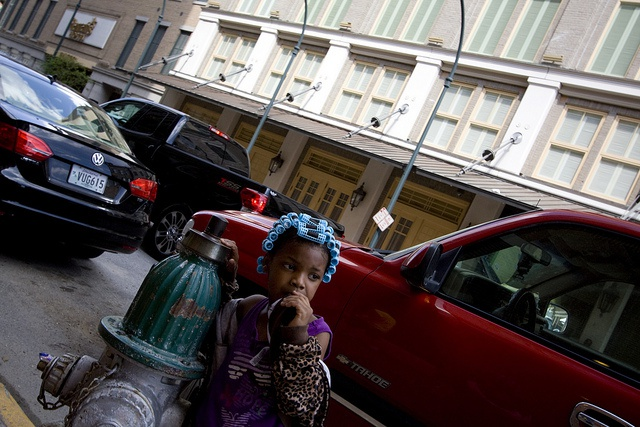Describe the objects in this image and their specific colors. I can see car in black, maroon, gray, and darkgray tones, car in black, gray, and darkgray tones, fire hydrant in black, gray, blue, and darkblue tones, people in black, gray, and maroon tones, and truck in black, gray, and darkgray tones in this image. 